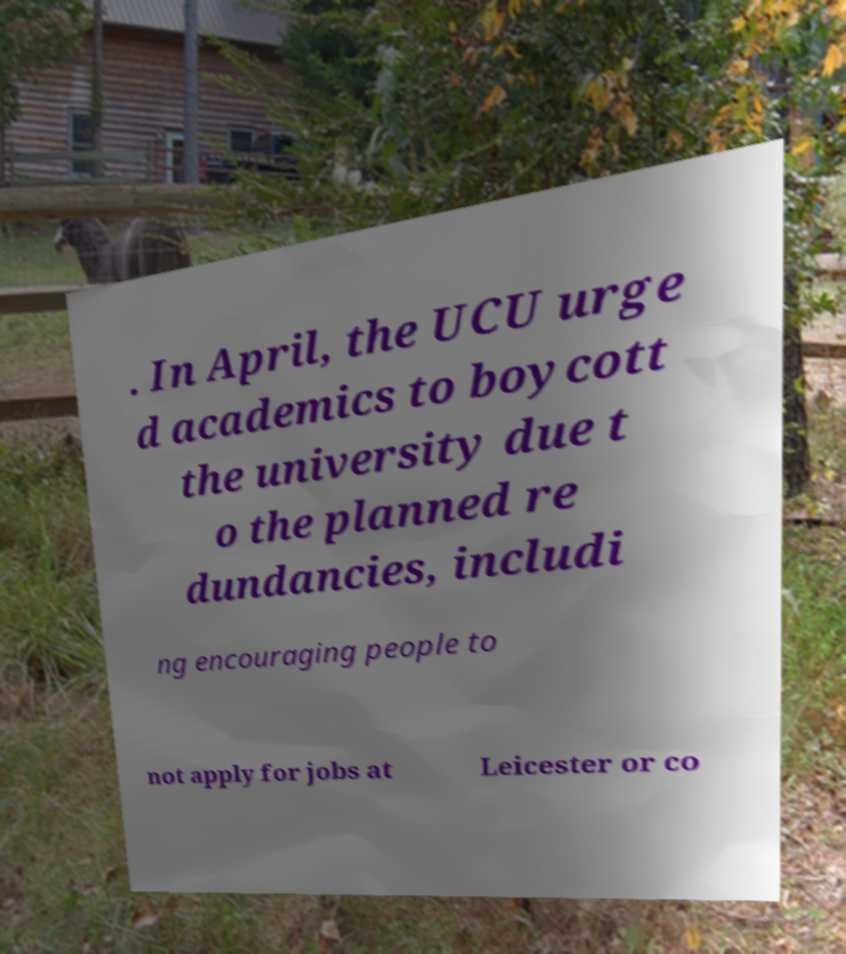I need the written content from this picture converted into text. Can you do that? . In April, the UCU urge d academics to boycott the university due t o the planned re dundancies, includi ng encouraging people to not apply for jobs at Leicester or co 